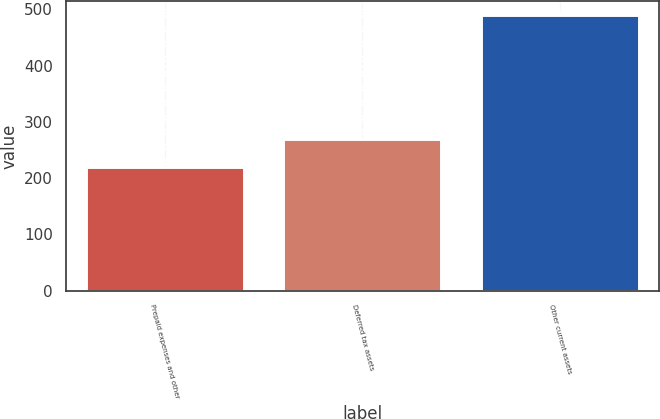Convert chart. <chart><loc_0><loc_0><loc_500><loc_500><bar_chart><fcel>Prepaid expenses and other<fcel>Deferred tax assets<fcel>Other current assets<nl><fcel>219.4<fcel>270.3<fcel>489.7<nl></chart> 